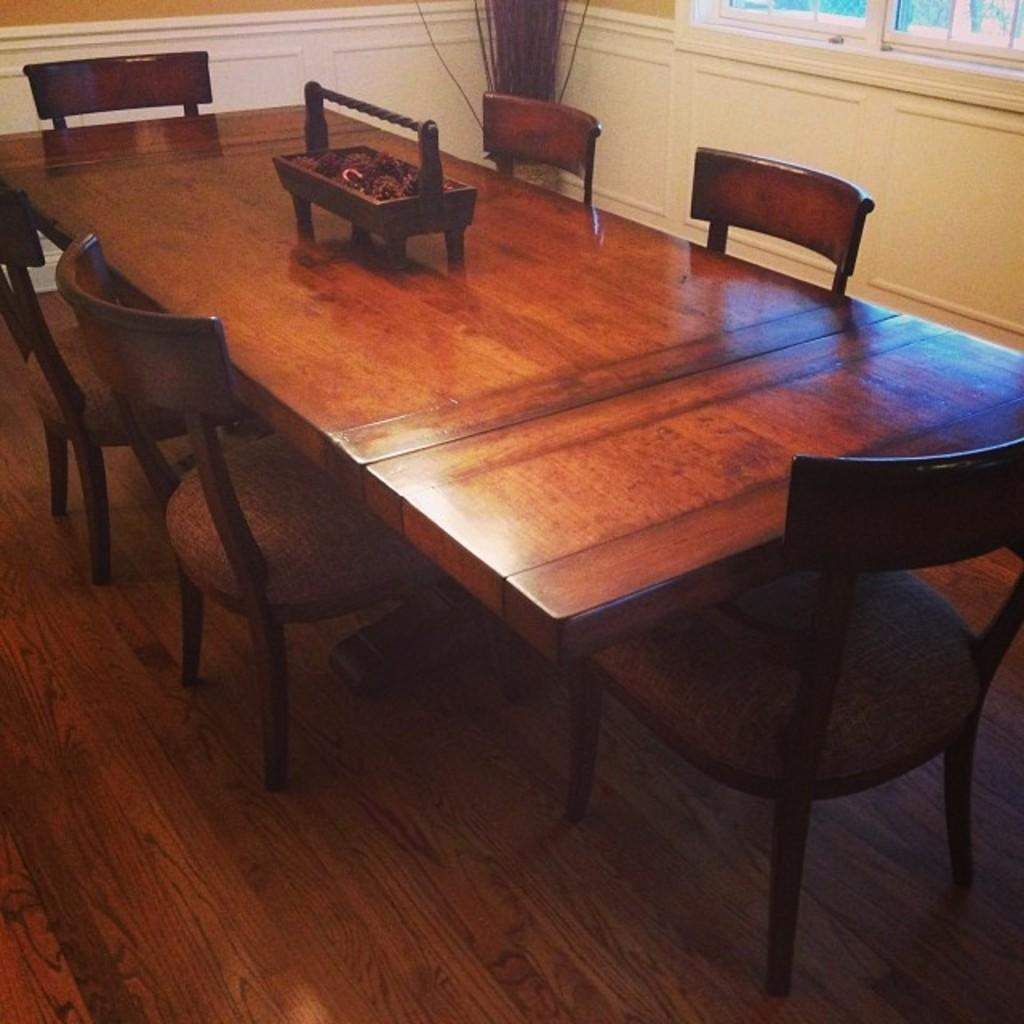What type of furniture is in the center of the image? There is a big dining table in the image. What accompanies the dining table? There are chairs around the dining table. What can be seen on the right side of the image? There appears to be a glass window on the right side of the image. Where is the scarecrow located in the image? There is no scarecrow present in the image. What type of furniture is in the bedroom in the image? The image does not show a bedroom, so it is not possible to determine what type of furniture might be present. 